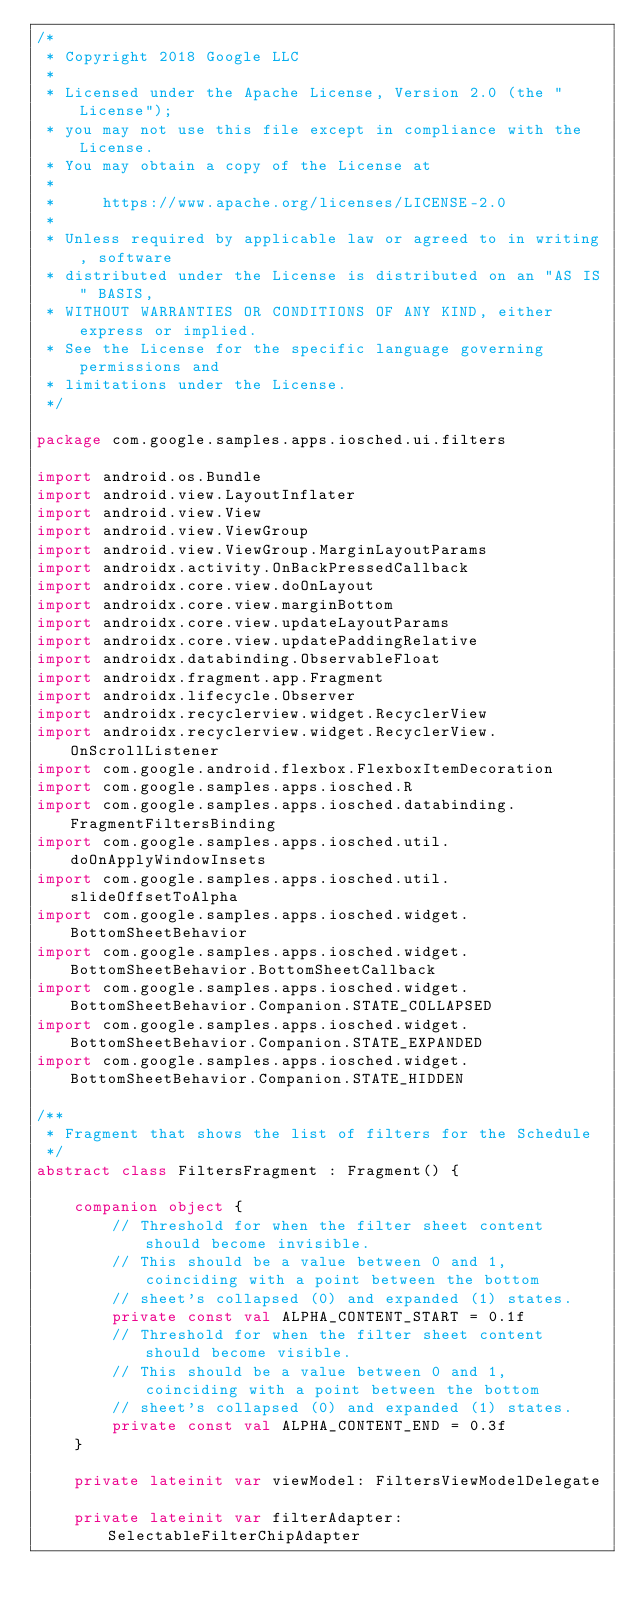Convert code to text. <code><loc_0><loc_0><loc_500><loc_500><_Kotlin_>/*
 * Copyright 2018 Google LLC
 *
 * Licensed under the Apache License, Version 2.0 (the "License");
 * you may not use this file except in compliance with the License.
 * You may obtain a copy of the License at
 *
 *     https://www.apache.org/licenses/LICENSE-2.0
 *
 * Unless required by applicable law or agreed to in writing, software
 * distributed under the License is distributed on an "AS IS" BASIS,
 * WITHOUT WARRANTIES OR CONDITIONS OF ANY KIND, either express or implied.
 * See the License for the specific language governing permissions and
 * limitations under the License.
 */

package com.google.samples.apps.iosched.ui.filters

import android.os.Bundle
import android.view.LayoutInflater
import android.view.View
import android.view.ViewGroup
import android.view.ViewGroup.MarginLayoutParams
import androidx.activity.OnBackPressedCallback
import androidx.core.view.doOnLayout
import androidx.core.view.marginBottom
import androidx.core.view.updateLayoutParams
import androidx.core.view.updatePaddingRelative
import androidx.databinding.ObservableFloat
import androidx.fragment.app.Fragment
import androidx.lifecycle.Observer
import androidx.recyclerview.widget.RecyclerView
import androidx.recyclerview.widget.RecyclerView.OnScrollListener
import com.google.android.flexbox.FlexboxItemDecoration
import com.google.samples.apps.iosched.R
import com.google.samples.apps.iosched.databinding.FragmentFiltersBinding
import com.google.samples.apps.iosched.util.doOnApplyWindowInsets
import com.google.samples.apps.iosched.util.slideOffsetToAlpha
import com.google.samples.apps.iosched.widget.BottomSheetBehavior
import com.google.samples.apps.iosched.widget.BottomSheetBehavior.BottomSheetCallback
import com.google.samples.apps.iosched.widget.BottomSheetBehavior.Companion.STATE_COLLAPSED
import com.google.samples.apps.iosched.widget.BottomSheetBehavior.Companion.STATE_EXPANDED
import com.google.samples.apps.iosched.widget.BottomSheetBehavior.Companion.STATE_HIDDEN

/**
 * Fragment that shows the list of filters for the Schedule
 */
abstract class FiltersFragment : Fragment() {

    companion object {
        // Threshold for when the filter sheet content should become invisible.
        // This should be a value between 0 and 1, coinciding with a point between the bottom
        // sheet's collapsed (0) and expanded (1) states.
        private const val ALPHA_CONTENT_START = 0.1f
        // Threshold for when the filter sheet content should become visible.
        // This should be a value between 0 and 1, coinciding with a point between the bottom
        // sheet's collapsed (0) and expanded (1) states.
        private const val ALPHA_CONTENT_END = 0.3f
    }

    private lateinit var viewModel: FiltersViewModelDelegate

    private lateinit var filterAdapter: SelectableFilterChipAdapter
</code> 